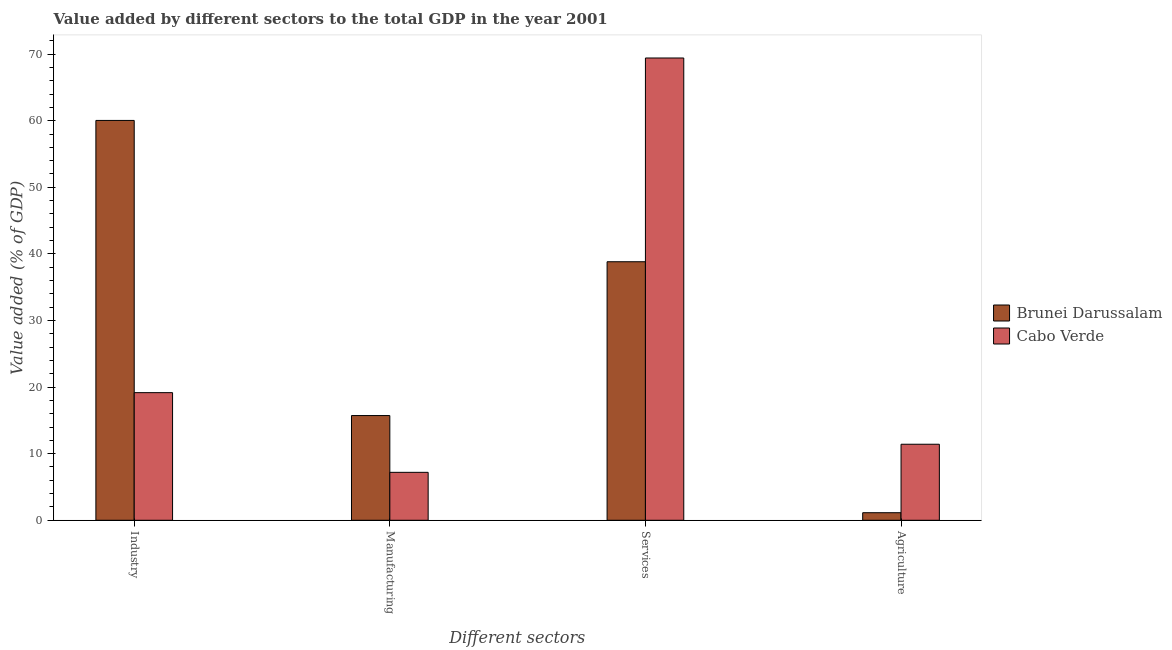How many bars are there on the 1st tick from the left?
Provide a succinct answer. 2. What is the label of the 4th group of bars from the left?
Give a very brief answer. Agriculture. What is the value added by services sector in Brunei Darussalam?
Make the answer very short. 38.82. Across all countries, what is the maximum value added by agricultural sector?
Give a very brief answer. 11.42. Across all countries, what is the minimum value added by manufacturing sector?
Ensure brevity in your answer.  7.2. In which country was the value added by agricultural sector maximum?
Offer a very short reply. Cabo Verde. In which country was the value added by industrial sector minimum?
Offer a terse response. Cabo Verde. What is the total value added by services sector in the graph?
Make the answer very short. 108.24. What is the difference between the value added by agricultural sector in Cabo Verde and that in Brunei Darussalam?
Give a very brief answer. 10.28. What is the difference between the value added by agricultural sector in Cabo Verde and the value added by services sector in Brunei Darussalam?
Offer a very short reply. -27.41. What is the average value added by industrial sector per country?
Keep it short and to the point. 39.6. What is the difference between the value added by manufacturing sector and value added by industrial sector in Cabo Verde?
Give a very brief answer. -11.97. In how many countries, is the value added by manufacturing sector greater than 48 %?
Make the answer very short. 0. What is the ratio of the value added by manufacturing sector in Cabo Verde to that in Brunei Darussalam?
Your answer should be compact. 0.46. What is the difference between the highest and the second highest value added by services sector?
Keep it short and to the point. 30.6. What is the difference between the highest and the lowest value added by industrial sector?
Make the answer very short. 40.88. Is the sum of the value added by industrial sector in Cabo Verde and Brunei Darussalam greater than the maximum value added by agricultural sector across all countries?
Give a very brief answer. Yes. What does the 1st bar from the left in Services represents?
Keep it short and to the point. Brunei Darussalam. What does the 2nd bar from the right in Agriculture represents?
Offer a very short reply. Brunei Darussalam. How many bars are there?
Offer a terse response. 8. Are all the bars in the graph horizontal?
Make the answer very short. No. What is the difference between two consecutive major ticks on the Y-axis?
Your answer should be compact. 10. Are the values on the major ticks of Y-axis written in scientific E-notation?
Make the answer very short. No. Does the graph contain grids?
Ensure brevity in your answer.  No. Where does the legend appear in the graph?
Provide a succinct answer. Center right. What is the title of the graph?
Provide a short and direct response. Value added by different sectors to the total GDP in the year 2001. Does "Macao" appear as one of the legend labels in the graph?
Provide a succinct answer. No. What is the label or title of the X-axis?
Your response must be concise. Different sectors. What is the label or title of the Y-axis?
Your response must be concise. Value added (% of GDP). What is the Value added (% of GDP) in Brunei Darussalam in Industry?
Offer a very short reply. 60.04. What is the Value added (% of GDP) in Cabo Verde in Industry?
Your response must be concise. 19.16. What is the Value added (% of GDP) of Brunei Darussalam in Manufacturing?
Make the answer very short. 15.73. What is the Value added (% of GDP) in Cabo Verde in Manufacturing?
Your response must be concise. 7.2. What is the Value added (% of GDP) in Brunei Darussalam in Services?
Offer a very short reply. 38.82. What is the Value added (% of GDP) in Cabo Verde in Services?
Your response must be concise. 69.42. What is the Value added (% of GDP) in Brunei Darussalam in Agriculture?
Your answer should be compact. 1.13. What is the Value added (% of GDP) of Cabo Verde in Agriculture?
Ensure brevity in your answer.  11.42. Across all Different sectors, what is the maximum Value added (% of GDP) of Brunei Darussalam?
Your response must be concise. 60.04. Across all Different sectors, what is the maximum Value added (% of GDP) of Cabo Verde?
Offer a very short reply. 69.42. Across all Different sectors, what is the minimum Value added (% of GDP) in Brunei Darussalam?
Your answer should be very brief. 1.13. Across all Different sectors, what is the minimum Value added (% of GDP) of Cabo Verde?
Provide a succinct answer. 7.2. What is the total Value added (% of GDP) in Brunei Darussalam in the graph?
Ensure brevity in your answer.  115.73. What is the total Value added (% of GDP) in Cabo Verde in the graph?
Provide a short and direct response. 107.2. What is the difference between the Value added (% of GDP) of Brunei Darussalam in Industry and that in Manufacturing?
Provide a succinct answer. 44.32. What is the difference between the Value added (% of GDP) of Cabo Verde in Industry and that in Manufacturing?
Provide a short and direct response. 11.97. What is the difference between the Value added (% of GDP) of Brunei Darussalam in Industry and that in Services?
Your answer should be compact. 21.22. What is the difference between the Value added (% of GDP) of Cabo Verde in Industry and that in Services?
Make the answer very short. -50.26. What is the difference between the Value added (% of GDP) in Brunei Darussalam in Industry and that in Agriculture?
Your answer should be very brief. 58.91. What is the difference between the Value added (% of GDP) of Cabo Verde in Industry and that in Agriculture?
Provide a short and direct response. 7.75. What is the difference between the Value added (% of GDP) of Brunei Darussalam in Manufacturing and that in Services?
Provide a short and direct response. -23.1. What is the difference between the Value added (% of GDP) in Cabo Verde in Manufacturing and that in Services?
Offer a terse response. -62.22. What is the difference between the Value added (% of GDP) in Brunei Darussalam in Manufacturing and that in Agriculture?
Provide a short and direct response. 14.59. What is the difference between the Value added (% of GDP) in Cabo Verde in Manufacturing and that in Agriculture?
Provide a short and direct response. -4.22. What is the difference between the Value added (% of GDP) in Brunei Darussalam in Services and that in Agriculture?
Ensure brevity in your answer.  37.69. What is the difference between the Value added (% of GDP) in Cabo Verde in Services and that in Agriculture?
Your response must be concise. 58. What is the difference between the Value added (% of GDP) of Brunei Darussalam in Industry and the Value added (% of GDP) of Cabo Verde in Manufacturing?
Provide a succinct answer. 52.85. What is the difference between the Value added (% of GDP) in Brunei Darussalam in Industry and the Value added (% of GDP) in Cabo Verde in Services?
Offer a very short reply. -9.38. What is the difference between the Value added (% of GDP) of Brunei Darussalam in Industry and the Value added (% of GDP) of Cabo Verde in Agriculture?
Your answer should be compact. 48.63. What is the difference between the Value added (% of GDP) of Brunei Darussalam in Manufacturing and the Value added (% of GDP) of Cabo Verde in Services?
Provide a succinct answer. -53.69. What is the difference between the Value added (% of GDP) in Brunei Darussalam in Manufacturing and the Value added (% of GDP) in Cabo Verde in Agriculture?
Your answer should be very brief. 4.31. What is the difference between the Value added (% of GDP) in Brunei Darussalam in Services and the Value added (% of GDP) in Cabo Verde in Agriculture?
Ensure brevity in your answer.  27.41. What is the average Value added (% of GDP) of Brunei Darussalam per Different sectors?
Offer a terse response. 28.93. What is the average Value added (% of GDP) of Cabo Verde per Different sectors?
Provide a short and direct response. 26.8. What is the difference between the Value added (% of GDP) of Brunei Darussalam and Value added (% of GDP) of Cabo Verde in Industry?
Provide a short and direct response. 40.88. What is the difference between the Value added (% of GDP) in Brunei Darussalam and Value added (% of GDP) in Cabo Verde in Manufacturing?
Give a very brief answer. 8.53. What is the difference between the Value added (% of GDP) in Brunei Darussalam and Value added (% of GDP) in Cabo Verde in Services?
Your response must be concise. -30.6. What is the difference between the Value added (% of GDP) in Brunei Darussalam and Value added (% of GDP) in Cabo Verde in Agriculture?
Make the answer very short. -10.28. What is the ratio of the Value added (% of GDP) of Brunei Darussalam in Industry to that in Manufacturing?
Your answer should be very brief. 3.82. What is the ratio of the Value added (% of GDP) of Cabo Verde in Industry to that in Manufacturing?
Make the answer very short. 2.66. What is the ratio of the Value added (% of GDP) of Brunei Darussalam in Industry to that in Services?
Provide a succinct answer. 1.55. What is the ratio of the Value added (% of GDP) in Cabo Verde in Industry to that in Services?
Offer a terse response. 0.28. What is the ratio of the Value added (% of GDP) in Brunei Darussalam in Industry to that in Agriculture?
Offer a terse response. 52.92. What is the ratio of the Value added (% of GDP) in Cabo Verde in Industry to that in Agriculture?
Your response must be concise. 1.68. What is the ratio of the Value added (% of GDP) of Brunei Darussalam in Manufacturing to that in Services?
Give a very brief answer. 0.41. What is the ratio of the Value added (% of GDP) of Cabo Verde in Manufacturing to that in Services?
Offer a terse response. 0.1. What is the ratio of the Value added (% of GDP) of Brunei Darussalam in Manufacturing to that in Agriculture?
Provide a short and direct response. 13.86. What is the ratio of the Value added (% of GDP) of Cabo Verde in Manufacturing to that in Agriculture?
Provide a succinct answer. 0.63. What is the ratio of the Value added (% of GDP) in Brunei Darussalam in Services to that in Agriculture?
Give a very brief answer. 34.22. What is the ratio of the Value added (% of GDP) of Cabo Verde in Services to that in Agriculture?
Keep it short and to the point. 6.08. What is the difference between the highest and the second highest Value added (% of GDP) of Brunei Darussalam?
Ensure brevity in your answer.  21.22. What is the difference between the highest and the second highest Value added (% of GDP) in Cabo Verde?
Make the answer very short. 50.26. What is the difference between the highest and the lowest Value added (% of GDP) of Brunei Darussalam?
Make the answer very short. 58.91. What is the difference between the highest and the lowest Value added (% of GDP) in Cabo Verde?
Offer a terse response. 62.22. 